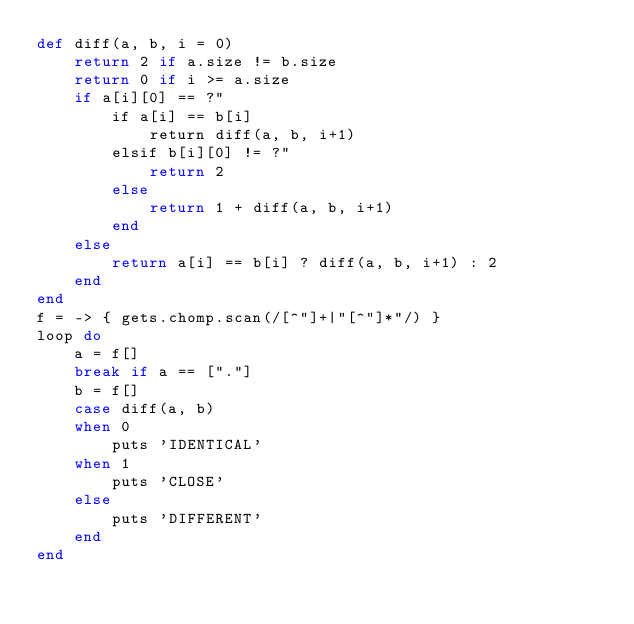Convert code to text. <code><loc_0><loc_0><loc_500><loc_500><_Ruby_>def diff(a, b, i = 0)
    return 2 if a.size != b.size
    return 0 if i >= a.size
    if a[i][0] == ?"
        if a[i] == b[i]
            return diff(a, b, i+1)
        elsif b[i][0] != ?"
            return 2
        else
            return 1 + diff(a, b, i+1)
        end
    else
        return a[i] == b[i] ? diff(a, b, i+1) : 2
    end
end
f = -> { gets.chomp.scan(/[^"]+|"[^"]*"/) }
loop do
    a = f[]
    break if a == ["."]
    b = f[]
    case diff(a, b)
    when 0
        puts 'IDENTICAL'
    when 1
        puts 'CLOSE'
    else
        puts 'DIFFERENT'
    end
end

</code> 